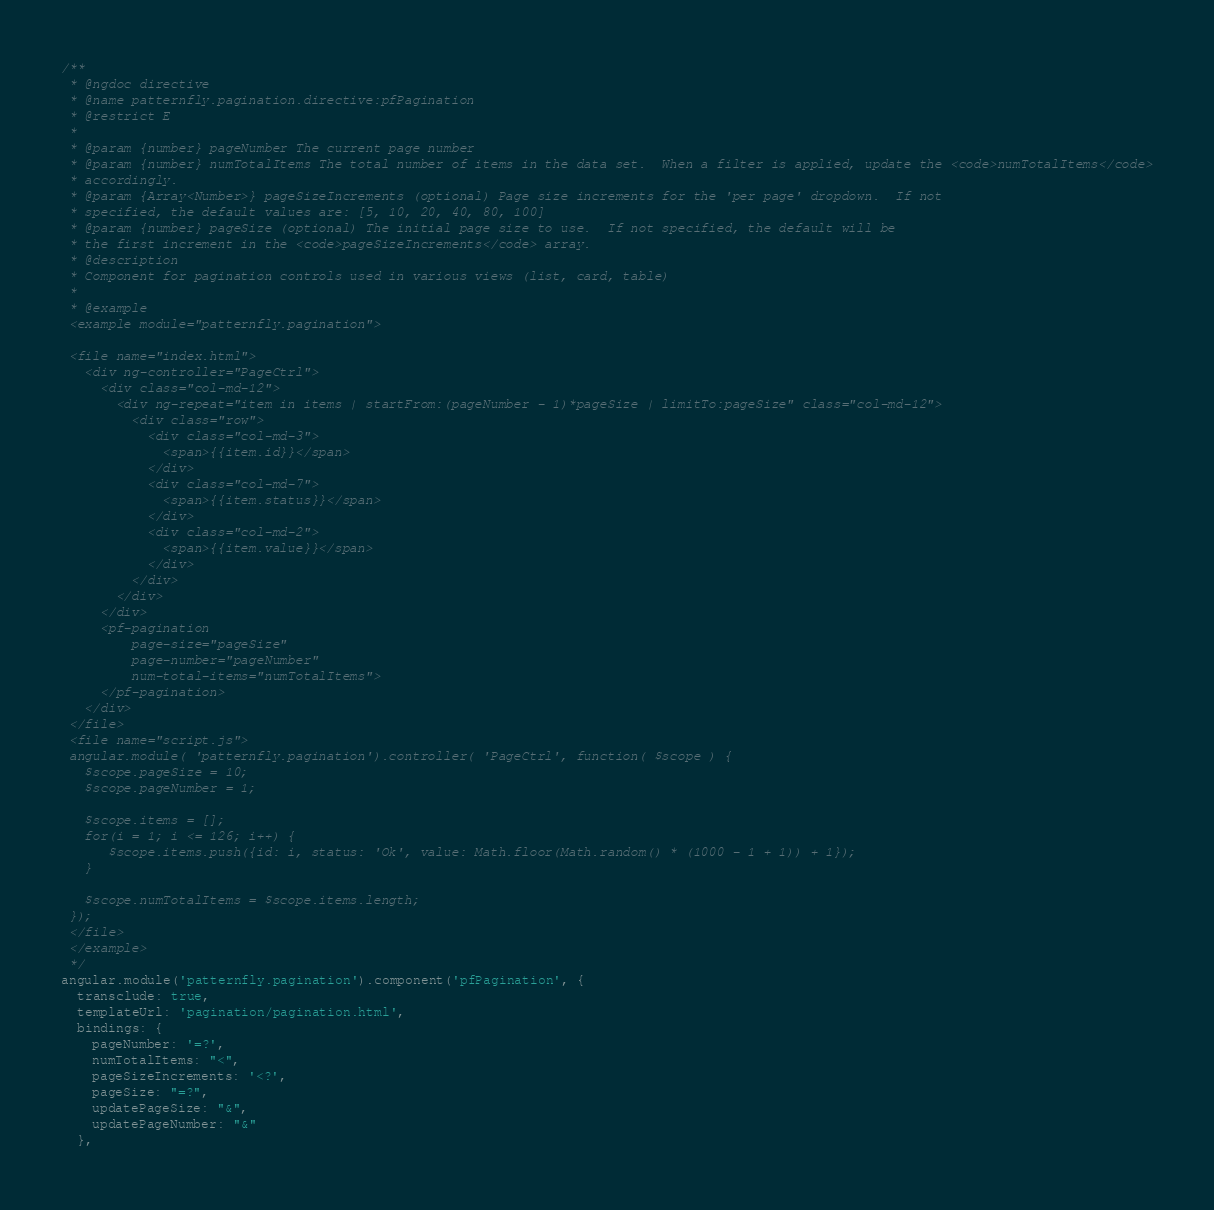<code> <loc_0><loc_0><loc_500><loc_500><_JavaScript_>/**
 * @ngdoc directive
 * @name patternfly.pagination.directive:pfPagination
 * @restrict E
 *
 * @param {number} pageNumber The current page number
 * @param {number} numTotalItems The total number of items in the data set.  When a filter is applied, update the <code>numTotalItems</code>
 * accordingly.
 * @param {Array<Number>} pageSizeIncrements (optional) Page size increments for the 'per page' dropdown.  If not
 * specified, the default values are: [5, 10, 20, 40, 80, 100]
 * @param {number} pageSize (optional) The initial page size to use.  If not specified, the default will be
 * the first increment in the <code>pageSizeIncrements</code> array.
 * @description
 * Component for pagination controls used in various views (list, card, table)
 *
 * @example
 <example module="patternfly.pagination">

 <file name="index.html">
   <div ng-controller="PageCtrl">
     <div class="col-md-12">
       <div ng-repeat="item in items | startFrom:(pageNumber - 1)*pageSize | limitTo:pageSize" class="col-md-12">
         <div class="row">
           <div class="col-md-3">
             <span>{{item.id}}</span>
           </div>
           <div class="col-md-7">
             <span>{{item.status}}</span>
           </div>
           <div class="col-md-2">
             <span>{{item.value}}</span>
           </div>
         </div>
       </div>
     </div>
     <pf-pagination
         page-size="pageSize"
         page-number="pageNumber"
         num-total-items="numTotalItems">
     </pf-pagination>
   </div>
 </file>
 <file name="script.js">
 angular.module( 'patternfly.pagination').controller( 'PageCtrl', function( $scope ) {
   $scope.pageSize = 10;
   $scope.pageNumber = 1;

   $scope.items = [];
   for(i = 1; i <= 126; i++) {
      $scope.items.push({id: i, status: 'Ok', value: Math.floor(Math.random() * (1000 - 1 + 1)) + 1});
   }

   $scope.numTotalItems = $scope.items.length;
 });
 </file>
 </example>
 */
angular.module('patternfly.pagination').component('pfPagination', {
  transclude: true,
  templateUrl: 'pagination/pagination.html',
  bindings: {
    pageNumber: '=?',
    numTotalItems: "<",
    pageSizeIncrements: '<?',
    pageSize: "=?",
    updatePageSize: "&",
    updatePageNumber: "&"
  },</code> 